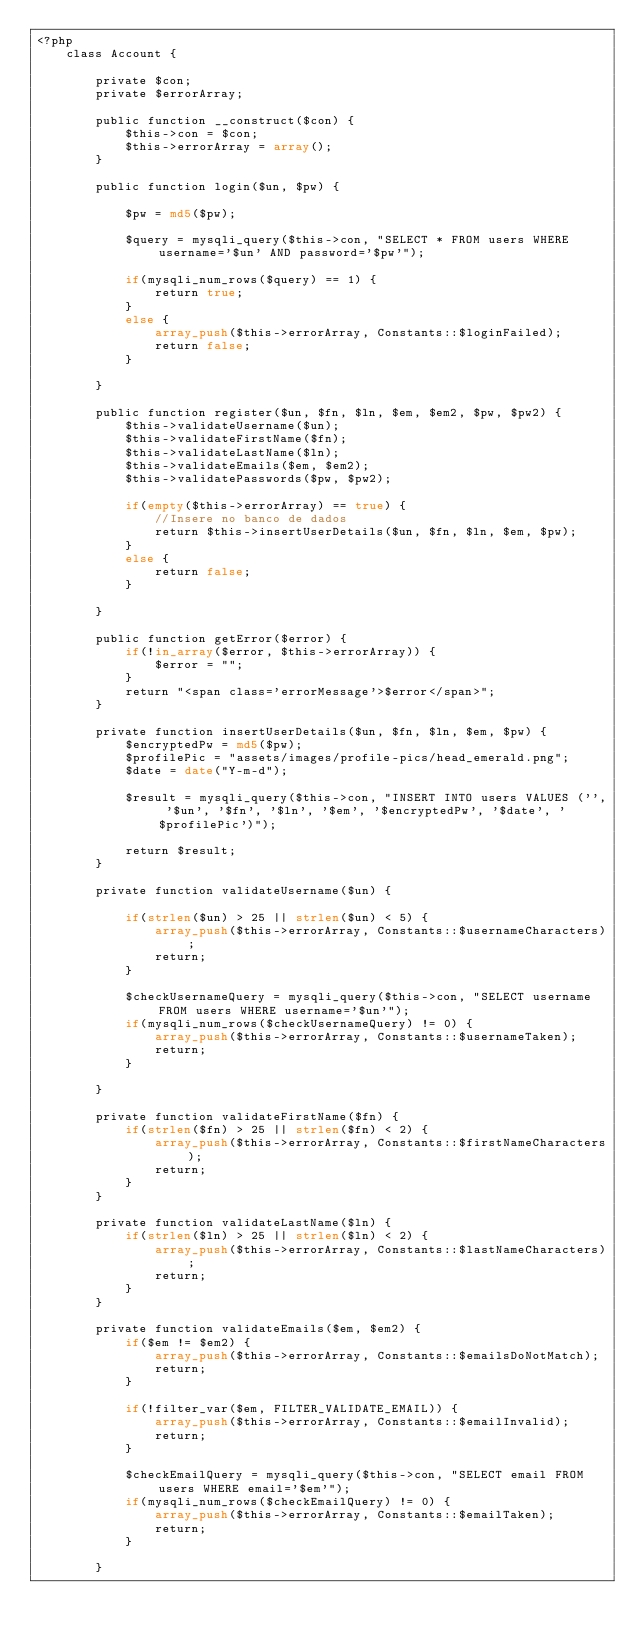<code> <loc_0><loc_0><loc_500><loc_500><_PHP_><?php
	class Account {

		private $con;
		private $errorArray;

		public function __construct($con) {
			$this->con = $con;
			$this->errorArray = array();
		}

		public function login($un, $pw) {

			$pw = md5($pw);

			$query = mysqli_query($this->con, "SELECT * FROM users WHERE username='$un' AND password='$pw'");

			if(mysqli_num_rows($query) == 1) {
				return true;
			}
			else {
				array_push($this->errorArray, Constants::$loginFailed);
				return false;
			}

		}

		public function register($un, $fn, $ln, $em, $em2, $pw, $pw2) {
			$this->validateUsername($un);
			$this->validateFirstName($fn);
			$this->validateLastName($ln);
			$this->validateEmails($em, $em2);
			$this->validatePasswords($pw, $pw2);

			if(empty($this->errorArray) == true) {
				//Insere no banco de dados
				return $this->insertUserDetails($un, $fn, $ln, $em, $pw);
			}
			else {
				return false;
			}

		}

		public function getError($error) {
			if(!in_array($error, $this->errorArray)) {
				$error = "";
			}
			return "<span class='errorMessage'>$error</span>";
		}

		private function insertUserDetails($un, $fn, $ln, $em, $pw) {
			$encryptedPw = md5($pw);
			$profilePic = "assets/images/profile-pics/head_emerald.png";
			$date = date("Y-m-d");

			$result = mysqli_query($this->con, "INSERT INTO users VALUES ('', '$un', '$fn', '$ln', '$em', '$encryptedPw', '$date', '$profilePic')");

			return $result;
		}

		private function validateUsername($un) {

			if(strlen($un) > 25 || strlen($un) < 5) {
				array_push($this->errorArray, Constants::$usernameCharacters);
				return;
			}

			$checkUsernameQuery = mysqli_query($this->con, "SELECT username FROM users WHERE username='$un'");
			if(mysqli_num_rows($checkUsernameQuery) != 0) {
				array_push($this->errorArray, Constants::$usernameTaken);
				return;
			}

		}

		private function validateFirstName($fn) {
			if(strlen($fn) > 25 || strlen($fn) < 2) {
				array_push($this->errorArray, Constants::$firstNameCharacters);
				return;
			}
		}

		private function validateLastName($ln) {
			if(strlen($ln) > 25 || strlen($ln) < 2) {
				array_push($this->errorArray, Constants::$lastNameCharacters);
				return;
			}
		}

		private function validateEmails($em, $em2) {
			if($em != $em2) {
				array_push($this->errorArray, Constants::$emailsDoNotMatch);
				return;
			}

			if(!filter_var($em, FILTER_VALIDATE_EMAIL)) {
				array_push($this->errorArray, Constants::$emailInvalid);
				return;
			}

			$checkEmailQuery = mysqli_query($this->con, "SELECT email FROM users WHERE email='$em'");
			if(mysqli_num_rows($checkEmailQuery) != 0) {
				array_push($this->errorArray, Constants::$emailTaken);
				return;
			}

		}
</code> 